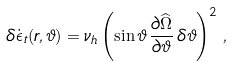<formula> <loc_0><loc_0><loc_500><loc_500>\delta \dot { \epsilon } _ { t } ( r , \vartheta ) = \nu _ { h } \left ( \sin \vartheta \, \frac { \partial \widehat { \Omega } } { \partial \vartheta } \, \delta \vartheta \right ) ^ { 2 } \, ,</formula> 